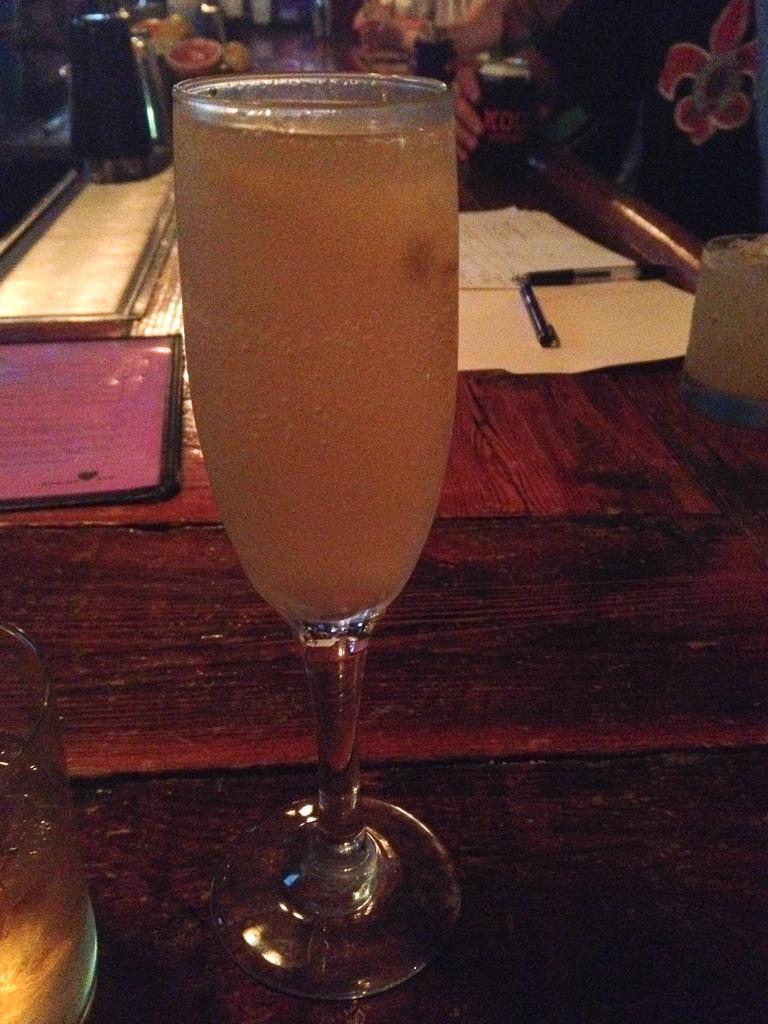What is the main piece of furniture in the image? There is a table in the image. What is placed on the table? There are objects on the table. Can you describe the variety of objects on the table? The objects on the table are of different kinds. Who is present in the image? There is a person standing in the image. What is the person holding? The person is holding an object. What type of animal is standing on the table in the image? There is no animal present on the table in the image. How many feet are visible on the person in the image? The image does not show the person's feet, so it is not possible to determine the number of feet visible. 